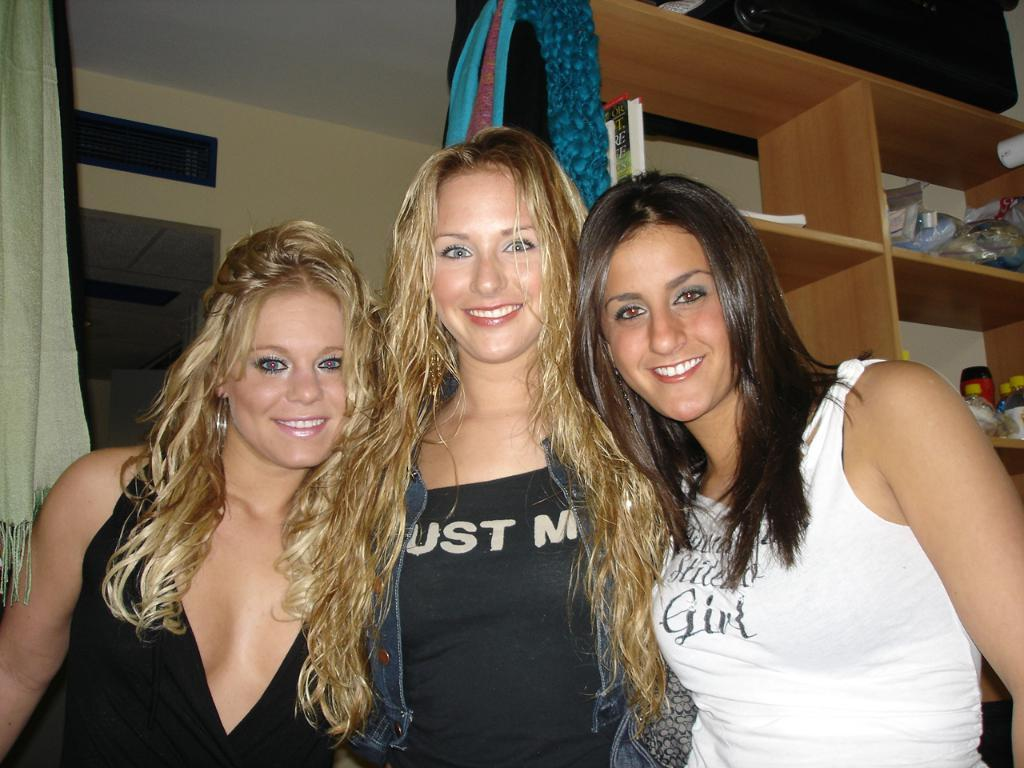How many women are in the image? There are three women in the image. What expression do the women have? The women are all smiling. What items can be seen on the shelves in the image? There are covers, bottles, books, and other things visible in the racks. What type of clothing is visible in the image? There are clothes visible in the image. Can you see a goat eating oatmeal while wearing a collar in the image? No, there is no goat, oatmeal, or collar present in the image. 